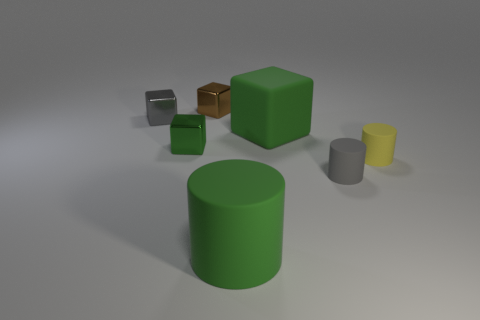Subtract all green blocks. How many were subtracted if there are1green blocks left? 1 Add 2 yellow things. How many objects exist? 9 Subtract all cubes. How many objects are left? 3 Add 4 green shiny objects. How many green shiny objects are left? 5 Add 6 blocks. How many blocks exist? 10 Subtract 0 brown balls. How many objects are left? 7 Subtract all brown shiny blocks. Subtract all brown cubes. How many objects are left? 5 